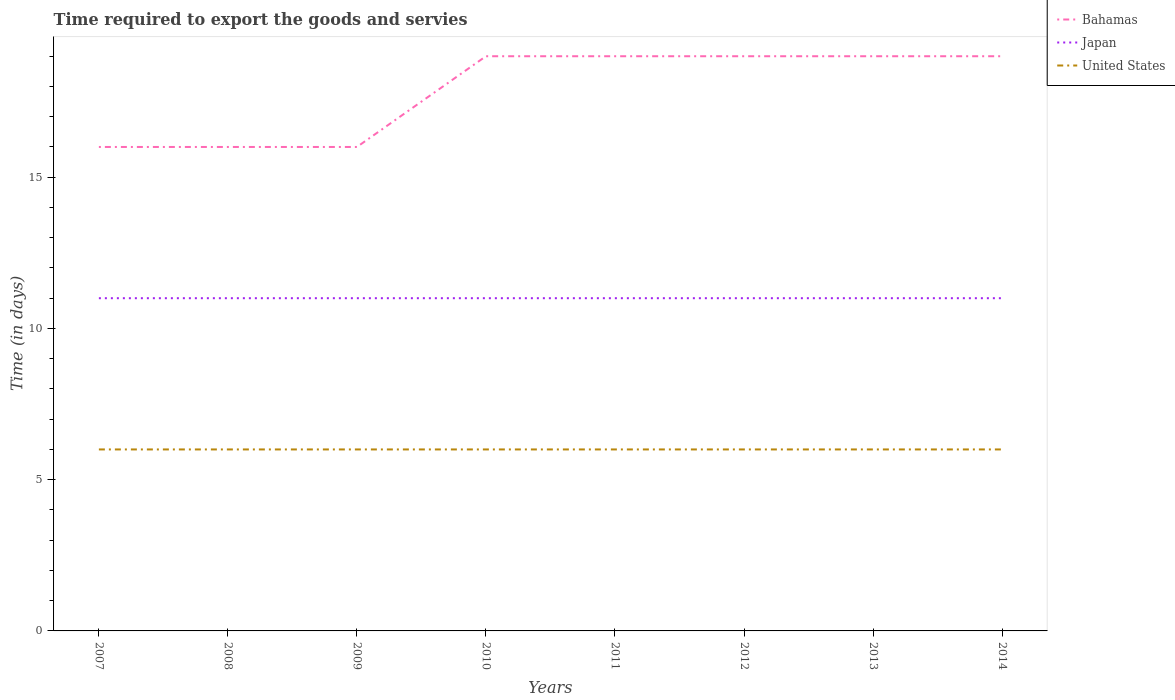Does the line corresponding to Bahamas intersect with the line corresponding to United States?
Give a very brief answer. No. Across all years, what is the maximum number of days required to export the goods and services in Japan?
Keep it short and to the point. 11. What is the total number of days required to export the goods and services in Bahamas in the graph?
Keep it short and to the point. -3. What is the difference between the highest and the second highest number of days required to export the goods and services in United States?
Offer a terse response. 0. What is the difference between the highest and the lowest number of days required to export the goods and services in United States?
Provide a succinct answer. 0. How many lines are there?
Provide a succinct answer. 3. How many years are there in the graph?
Offer a terse response. 8. Are the values on the major ticks of Y-axis written in scientific E-notation?
Your answer should be very brief. No. Does the graph contain grids?
Make the answer very short. No. Where does the legend appear in the graph?
Give a very brief answer. Top right. How many legend labels are there?
Your response must be concise. 3. How are the legend labels stacked?
Your response must be concise. Vertical. What is the title of the graph?
Ensure brevity in your answer.  Time required to export the goods and servies. What is the label or title of the Y-axis?
Your answer should be compact. Time (in days). What is the Time (in days) in Bahamas in 2007?
Give a very brief answer. 16. What is the Time (in days) of United States in 2007?
Offer a very short reply. 6. What is the Time (in days) of United States in 2008?
Your answer should be very brief. 6. What is the Time (in days) of Japan in 2009?
Your answer should be very brief. 11. What is the Time (in days) of United States in 2009?
Provide a succinct answer. 6. What is the Time (in days) of Bahamas in 2010?
Your answer should be compact. 19. What is the Time (in days) of United States in 2010?
Offer a very short reply. 6. What is the Time (in days) of Bahamas in 2011?
Your answer should be compact. 19. What is the Time (in days) in Japan in 2011?
Your answer should be compact. 11. What is the Time (in days) in United States in 2011?
Keep it short and to the point. 6. What is the Time (in days) in Japan in 2012?
Keep it short and to the point. 11. What is the Time (in days) of Japan in 2013?
Make the answer very short. 11. What is the Time (in days) of United States in 2013?
Your response must be concise. 6. What is the Time (in days) of Japan in 2014?
Make the answer very short. 11. What is the Time (in days) of United States in 2014?
Your answer should be very brief. 6. Across all years, what is the maximum Time (in days) in Bahamas?
Give a very brief answer. 19. Across all years, what is the maximum Time (in days) of Japan?
Ensure brevity in your answer.  11. Across all years, what is the minimum Time (in days) of Bahamas?
Offer a terse response. 16. Across all years, what is the minimum Time (in days) in Japan?
Keep it short and to the point. 11. What is the total Time (in days) in Bahamas in the graph?
Your answer should be compact. 143. What is the total Time (in days) in Japan in the graph?
Ensure brevity in your answer.  88. What is the difference between the Time (in days) of Bahamas in 2007 and that in 2008?
Offer a very short reply. 0. What is the difference between the Time (in days) in United States in 2007 and that in 2008?
Offer a very short reply. 0. What is the difference between the Time (in days) in Bahamas in 2007 and that in 2009?
Your answer should be compact. 0. What is the difference between the Time (in days) in United States in 2007 and that in 2009?
Your response must be concise. 0. What is the difference between the Time (in days) in Bahamas in 2007 and that in 2010?
Offer a very short reply. -3. What is the difference between the Time (in days) in United States in 2007 and that in 2010?
Keep it short and to the point. 0. What is the difference between the Time (in days) of United States in 2007 and that in 2011?
Your answer should be very brief. 0. What is the difference between the Time (in days) in Bahamas in 2007 and that in 2013?
Offer a terse response. -3. What is the difference between the Time (in days) of Japan in 2007 and that in 2013?
Keep it short and to the point. 0. What is the difference between the Time (in days) of United States in 2007 and that in 2013?
Your answer should be very brief. 0. What is the difference between the Time (in days) in Bahamas in 2007 and that in 2014?
Make the answer very short. -3. What is the difference between the Time (in days) of United States in 2008 and that in 2009?
Your answer should be very brief. 0. What is the difference between the Time (in days) of Japan in 2008 and that in 2010?
Offer a terse response. 0. What is the difference between the Time (in days) in United States in 2008 and that in 2010?
Provide a short and direct response. 0. What is the difference between the Time (in days) of Japan in 2008 and that in 2011?
Provide a succinct answer. 0. What is the difference between the Time (in days) in United States in 2008 and that in 2011?
Ensure brevity in your answer.  0. What is the difference between the Time (in days) in Japan in 2008 and that in 2013?
Offer a terse response. 0. What is the difference between the Time (in days) of United States in 2008 and that in 2013?
Ensure brevity in your answer.  0. What is the difference between the Time (in days) in Bahamas in 2008 and that in 2014?
Ensure brevity in your answer.  -3. What is the difference between the Time (in days) in Japan in 2008 and that in 2014?
Your answer should be compact. 0. What is the difference between the Time (in days) in Bahamas in 2009 and that in 2010?
Ensure brevity in your answer.  -3. What is the difference between the Time (in days) in Japan in 2009 and that in 2010?
Offer a terse response. 0. What is the difference between the Time (in days) in United States in 2009 and that in 2011?
Your response must be concise. 0. What is the difference between the Time (in days) of United States in 2009 and that in 2013?
Keep it short and to the point. 0. What is the difference between the Time (in days) in Japan in 2009 and that in 2014?
Offer a terse response. 0. What is the difference between the Time (in days) of Bahamas in 2010 and that in 2011?
Offer a terse response. 0. What is the difference between the Time (in days) in Bahamas in 2010 and that in 2012?
Give a very brief answer. 0. What is the difference between the Time (in days) in United States in 2010 and that in 2012?
Your response must be concise. 0. What is the difference between the Time (in days) of Japan in 2010 and that in 2013?
Your response must be concise. 0. What is the difference between the Time (in days) in Japan in 2010 and that in 2014?
Your response must be concise. 0. What is the difference between the Time (in days) in Japan in 2011 and that in 2012?
Give a very brief answer. 0. What is the difference between the Time (in days) of Bahamas in 2011 and that in 2013?
Offer a terse response. 0. What is the difference between the Time (in days) in Japan in 2011 and that in 2013?
Ensure brevity in your answer.  0. What is the difference between the Time (in days) of Bahamas in 2011 and that in 2014?
Make the answer very short. 0. What is the difference between the Time (in days) of United States in 2011 and that in 2014?
Offer a very short reply. 0. What is the difference between the Time (in days) in Bahamas in 2012 and that in 2013?
Ensure brevity in your answer.  0. What is the difference between the Time (in days) in Japan in 2012 and that in 2013?
Your answer should be compact. 0. What is the difference between the Time (in days) of United States in 2012 and that in 2013?
Your answer should be compact. 0. What is the difference between the Time (in days) of Japan in 2012 and that in 2014?
Provide a succinct answer. 0. What is the difference between the Time (in days) of Bahamas in 2007 and the Time (in days) of Japan in 2009?
Make the answer very short. 5. What is the difference between the Time (in days) of Japan in 2007 and the Time (in days) of United States in 2009?
Provide a short and direct response. 5. What is the difference between the Time (in days) in Japan in 2007 and the Time (in days) in United States in 2010?
Your answer should be very brief. 5. What is the difference between the Time (in days) in Bahamas in 2007 and the Time (in days) in United States in 2011?
Your response must be concise. 10. What is the difference between the Time (in days) of Japan in 2007 and the Time (in days) of United States in 2011?
Your answer should be very brief. 5. What is the difference between the Time (in days) in Bahamas in 2007 and the Time (in days) in Japan in 2012?
Ensure brevity in your answer.  5. What is the difference between the Time (in days) in Bahamas in 2007 and the Time (in days) in Japan in 2013?
Ensure brevity in your answer.  5. What is the difference between the Time (in days) in Bahamas in 2007 and the Time (in days) in Japan in 2014?
Provide a succinct answer. 5. What is the difference between the Time (in days) in Japan in 2007 and the Time (in days) in United States in 2014?
Offer a very short reply. 5. What is the difference between the Time (in days) of Bahamas in 2008 and the Time (in days) of Japan in 2009?
Provide a succinct answer. 5. What is the difference between the Time (in days) in Bahamas in 2008 and the Time (in days) in United States in 2009?
Provide a succinct answer. 10. What is the difference between the Time (in days) of Bahamas in 2008 and the Time (in days) of Japan in 2010?
Ensure brevity in your answer.  5. What is the difference between the Time (in days) of Bahamas in 2008 and the Time (in days) of United States in 2011?
Provide a succinct answer. 10. What is the difference between the Time (in days) of Japan in 2008 and the Time (in days) of United States in 2011?
Your response must be concise. 5. What is the difference between the Time (in days) of Bahamas in 2008 and the Time (in days) of United States in 2012?
Offer a very short reply. 10. What is the difference between the Time (in days) of Japan in 2008 and the Time (in days) of United States in 2012?
Offer a very short reply. 5. What is the difference between the Time (in days) in Bahamas in 2008 and the Time (in days) in Japan in 2013?
Offer a terse response. 5. What is the difference between the Time (in days) in Bahamas in 2008 and the Time (in days) in United States in 2014?
Your answer should be very brief. 10. What is the difference between the Time (in days) in Bahamas in 2009 and the Time (in days) in United States in 2010?
Give a very brief answer. 10. What is the difference between the Time (in days) in Japan in 2009 and the Time (in days) in United States in 2010?
Provide a short and direct response. 5. What is the difference between the Time (in days) in Bahamas in 2009 and the Time (in days) in United States in 2011?
Give a very brief answer. 10. What is the difference between the Time (in days) in Japan in 2009 and the Time (in days) in United States in 2011?
Offer a very short reply. 5. What is the difference between the Time (in days) in Bahamas in 2009 and the Time (in days) in United States in 2014?
Provide a short and direct response. 10. What is the difference between the Time (in days) in Japan in 2009 and the Time (in days) in United States in 2014?
Your response must be concise. 5. What is the difference between the Time (in days) in Bahamas in 2010 and the Time (in days) in United States in 2012?
Your answer should be compact. 13. What is the difference between the Time (in days) of Japan in 2010 and the Time (in days) of United States in 2013?
Give a very brief answer. 5. What is the difference between the Time (in days) of Japan in 2010 and the Time (in days) of United States in 2014?
Your response must be concise. 5. What is the difference between the Time (in days) of Bahamas in 2011 and the Time (in days) of Japan in 2012?
Make the answer very short. 8. What is the difference between the Time (in days) of Bahamas in 2011 and the Time (in days) of United States in 2012?
Provide a succinct answer. 13. What is the difference between the Time (in days) of Japan in 2011 and the Time (in days) of United States in 2012?
Keep it short and to the point. 5. What is the difference between the Time (in days) in Bahamas in 2011 and the Time (in days) in Japan in 2013?
Give a very brief answer. 8. What is the difference between the Time (in days) of Bahamas in 2011 and the Time (in days) of Japan in 2014?
Provide a short and direct response. 8. What is the difference between the Time (in days) of Bahamas in 2011 and the Time (in days) of United States in 2014?
Your response must be concise. 13. What is the difference between the Time (in days) of Japan in 2011 and the Time (in days) of United States in 2014?
Give a very brief answer. 5. What is the difference between the Time (in days) of Bahamas in 2012 and the Time (in days) of United States in 2013?
Your answer should be compact. 13. What is the difference between the Time (in days) of Japan in 2012 and the Time (in days) of United States in 2013?
Keep it short and to the point. 5. What is the difference between the Time (in days) of Bahamas in 2012 and the Time (in days) of Japan in 2014?
Make the answer very short. 8. What is the difference between the Time (in days) of Bahamas in 2012 and the Time (in days) of United States in 2014?
Provide a short and direct response. 13. What is the difference between the Time (in days) of Bahamas in 2013 and the Time (in days) of Japan in 2014?
Give a very brief answer. 8. What is the difference between the Time (in days) in Bahamas in 2013 and the Time (in days) in United States in 2014?
Keep it short and to the point. 13. What is the average Time (in days) of Bahamas per year?
Give a very brief answer. 17.88. What is the average Time (in days) of United States per year?
Give a very brief answer. 6. In the year 2007, what is the difference between the Time (in days) in Bahamas and Time (in days) in Japan?
Your answer should be very brief. 5. In the year 2007, what is the difference between the Time (in days) of Bahamas and Time (in days) of United States?
Give a very brief answer. 10. In the year 2008, what is the difference between the Time (in days) in Bahamas and Time (in days) in United States?
Make the answer very short. 10. In the year 2008, what is the difference between the Time (in days) in Japan and Time (in days) in United States?
Give a very brief answer. 5. In the year 2010, what is the difference between the Time (in days) of Japan and Time (in days) of United States?
Provide a short and direct response. 5. In the year 2011, what is the difference between the Time (in days) in Bahamas and Time (in days) in United States?
Make the answer very short. 13. In the year 2011, what is the difference between the Time (in days) in Japan and Time (in days) in United States?
Offer a terse response. 5. In the year 2012, what is the difference between the Time (in days) in Bahamas and Time (in days) in Japan?
Keep it short and to the point. 8. In the year 2014, what is the difference between the Time (in days) of Bahamas and Time (in days) of Japan?
Your answer should be very brief. 8. In the year 2014, what is the difference between the Time (in days) of Bahamas and Time (in days) of United States?
Your response must be concise. 13. In the year 2014, what is the difference between the Time (in days) in Japan and Time (in days) in United States?
Give a very brief answer. 5. What is the ratio of the Time (in days) in Bahamas in 2007 to that in 2008?
Give a very brief answer. 1. What is the ratio of the Time (in days) of Japan in 2007 to that in 2008?
Offer a very short reply. 1. What is the ratio of the Time (in days) in United States in 2007 to that in 2008?
Offer a terse response. 1. What is the ratio of the Time (in days) of United States in 2007 to that in 2009?
Your response must be concise. 1. What is the ratio of the Time (in days) of Bahamas in 2007 to that in 2010?
Provide a succinct answer. 0.84. What is the ratio of the Time (in days) of United States in 2007 to that in 2010?
Offer a terse response. 1. What is the ratio of the Time (in days) of Bahamas in 2007 to that in 2011?
Ensure brevity in your answer.  0.84. What is the ratio of the Time (in days) of Bahamas in 2007 to that in 2012?
Your response must be concise. 0.84. What is the ratio of the Time (in days) of Japan in 2007 to that in 2012?
Your response must be concise. 1. What is the ratio of the Time (in days) in Bahamas in 2007 to that in 2013?
Ensure brevity in your answer.  0.84. What is the ratio of the Time (in days) in Japan in 2007 to that in 2013?
Offer a very short reply. 1. What is the ratio of the Time (in days) in United States in 2007 to that in 2013?
Offer a terse response. 1. What is the ratio of the Time (in days) of Bahamas in 2007 to that in 2014?
Provide a succinct answer. 0.84. What is the ratio of the Time (in days) of Japan in 2007 to that in 2014?
Offer a very short reply. 1. What is the ratio of the Time (in days) of United States in 2007 to that in 2014?
Your answer should be very brief. 1. What is the ratio of the Time (in days) in Bahamas in 2008 to that in 2009?
Keep it short and to the point. 1. What is the ratio of the Time (in days) in Japan in 2008 to that in 2009?
Offer a terse response. 1. What is the ratio of the Time (in days) in Bahamas in 2008 to that in 2010?
Ensure brevity in your answer.  0.84. What is the ratio of the Time (in days) of Japan in 2008 to that in 2010?
Keep it short and to the point. 1. What is the ratio of the Time (in days) of United States in 2008 to that in 2010?
Offer a very short reply. 1. What is the ratio of the Time (in days) in Bahamas in 2008 to that in 2011?
Offer a very short reply. 0.84. What is the ratio of the Time (in days) in Bahamas in 2008 to that in 2012?
Offer a very short reply. 0.84. What is the ratio of the Time (in days) of Japan in 2008 to that in 2012?
Offer a very short reply. 1. What is the ratio of the Time (in days) in Bahamas in 2008 to that in 2013?
Your answer should be very brief. 0.84. What is the ratio of the Time (in days) in Japan in 2008 to that in 2013?
Provide a short and direct response. 1. What is the ratio of the Time (in days) in Bahamas in 2008 to that in 2014?
Give a very brief answer. 0.84. What is the ratio of the Time (in days) in Japan in 2008 to that in 2014?
Your answer should be very brief. 1. What is the ratio of the Time (in days) of United States in 2008 to that in 2014?
Give a very brief answer. 1. What is the ratio of the Time (in days) in Bahamas in 2009 to that in 2010?
Offer a very short reply. 0.84. What is the ratio of the Time (in days) in United States in 2009 to that in 2010?
Provide a short and direct response. 1. What is the ratio of the Time (in days) in Bahamas in 2009 to that in 2011?
Give a very brief answer. 0.84. What is the ratio of the Time (in days) in Japan in 2009 to that in 2011?
Give a very brief answer. 1. What is the ratio of the Time (in days) of Bahamas in 2009 to that in 2012?
Provide a short and direct response. 0.84. What is the ratio of the Time (in days) in United States in 2009 to that in 2012?
Give a very brief answer. 1. What is the ratio of the Time (in days) in Bahamas in 2009 to that in 2013?
Give a very brief answer. 0.84. What is the ratio of the Time (in days) in United States in 2009 to that in 2013?
Make the answer very short. 1. What is the ratio of the Time (in days) in Bahamas in 2009 to that in 2014?
Your response must be concise. 0.84. What is the ratio of the Time (in days) in Japan in 2009 to that in 2014?
Your answer should be compact. 1. What is the ratio of the Time (in days) of United States in 2009 to that in 2014?
Your answer should be compact. 1. What is the ratio of the Time (in days) of Bahamas in 2010 to that in 2012?
Offer a terse response. 1. What is the ratio of the Time (in days) of United States in 2010 to that in 2012?
Keep it short and to the point. 1. What is the ratio of the Time (in days) in Japan in 2010 to that in 2013?
Keep it short and to the point. 1. What is the ratio of the Time (in days) in Bahamas in 2010 to that in 2014?
Make the answer very short. 1. What is the ratio of the Time (in days) in Japan in 2010 to that in 2014?
Give a very brief answer. 1. What is the ratio of the Time (in days) in United States in 2010 to that in 2014?
Ensure brevity in your answer.  1. What is the ratio of the Time (in days) in Japan in 2011 to that in 2012?
Provide a short and direct response. 1. What is the ratio of the Time (in days) in United States in 2011 to that in 2012?
Keep it short and to the point. 1. What is the ratio of the Time (in days) in Bahamas in 2011 to that in 2013?
Keep it short and to the point. 1. What is the ratio of the Time (in days) in United States in 2011 to that in 2013?
Your answer should be compact. 1. What is the ratio of the Time (in days) in United States in 2011 to that in 2014?
Your answer should be very brief. 1. What is the difference between the highest and the lowest Time (in days) of Bahamas?
Make the answer very short. 3. 